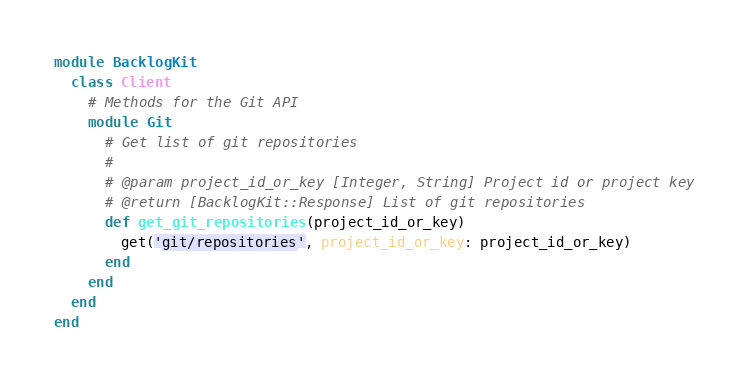<code> <loc_0><loc_0><loc_500><loc_500><_Ruby_>module BacklogKit
  class Client
    # Methods for the Git API
    module Git
      # Get list of git repositories
      #
      # @param project_id_or_key [Integer, String] Project id or project key
      # @return [BacklogKit::Response] List of git repositories
      def get_git_repositories(project_id_or_key)
        get('git/repositories', project_id_or_key: project_id_or_key)
      end
    end
  end
end
</code> 